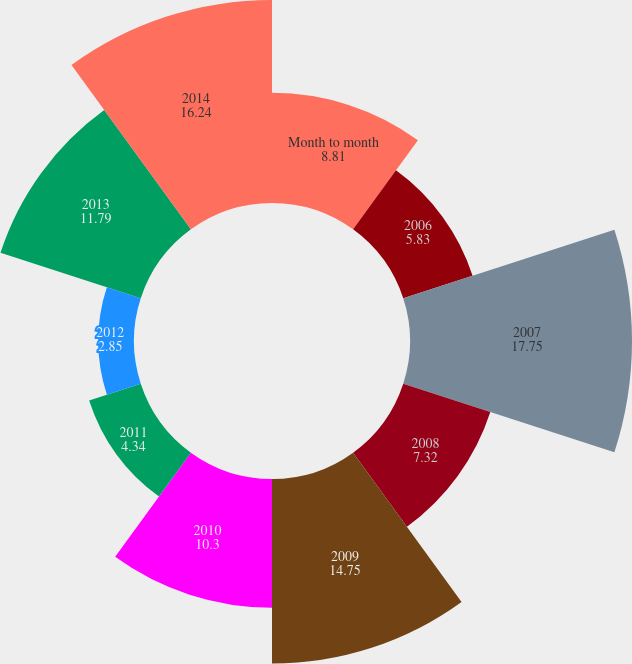Convert chart. <chart><loc_0><loc_0><loc_500><loc_500><pie_chart><fcel>Month to month<fcel>2006<fcel>2007<fcel>2008<fcel>2009<fcel>2010<fcel>2011<fcel>2012<fcel>2013<fcel>2014<nl><fcel>8.81%<fcel>5.83%<fcel>17.75%<fcel>7.32%<fcel>14.75%<fcel>10.3%<fcel>4.34%<fcel>2.85%<fcel>11.79%<fcel>16.24%<nl></chart> 